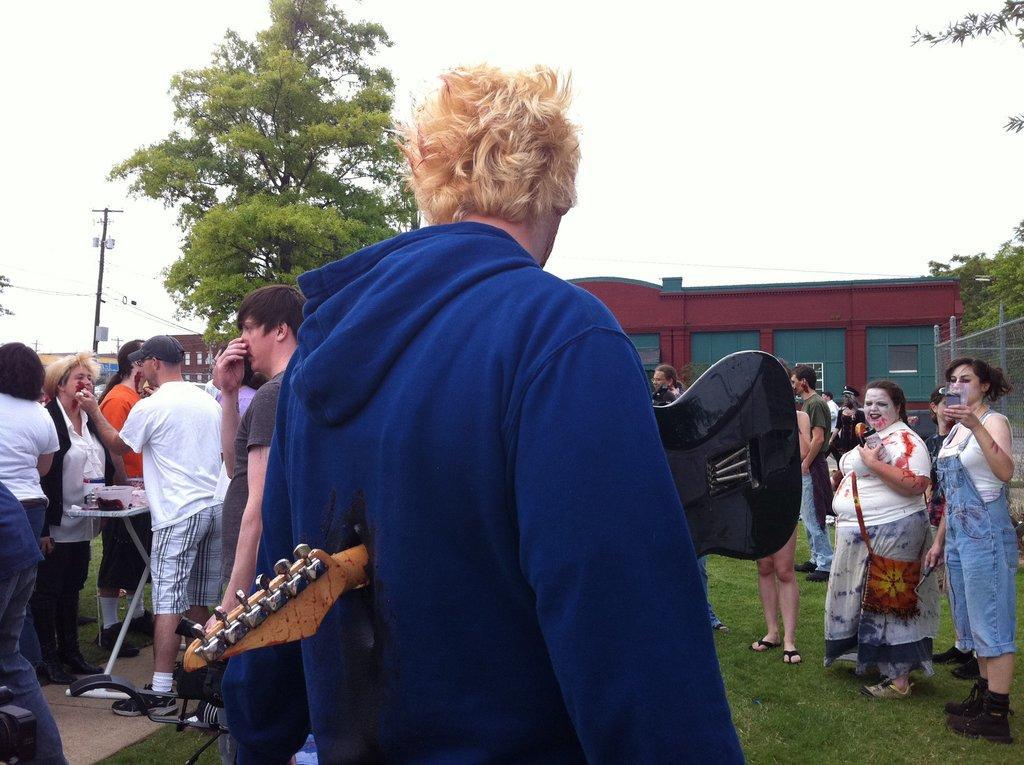How would you summarize this image in a sentence or two? In this image we can see some group of persons standing on the ground holding some objects in their hands, at the foreground of the image there is a person wearing blue color sweater holding guitar in his hands and at the background of the image there are some houses, trees, electric poles and clear sky. 